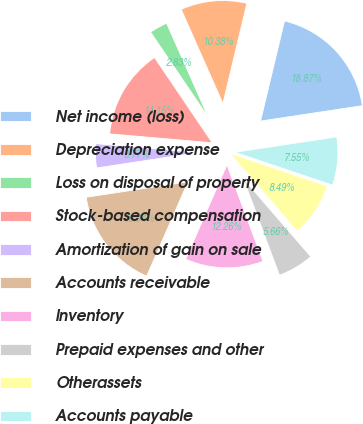Convert chart. <chart><loc_0><loc_0><loc_500><loc_500><pie_chart><fcel>Net income (loss)<fcel>Depreciation expense<fcel>Loss on disposal of property<fcel>Stock-based compensation<fcel>Amortization of gain on sale<fcel>Accounts receivable<fcel>Inventory<fcel>Prepaid expenses and other<fcel>Otherassets<fcel>Accounts payable<nl><fcel>18.87%<fcel>10.38%<fcel>2.83%<fcel>14.15%<fcel>3.77%<fcel>16.04%<fcel>12.26%<fcel>5.66%<fcel>8.49%<fcel>7.55%<nl></chart> 